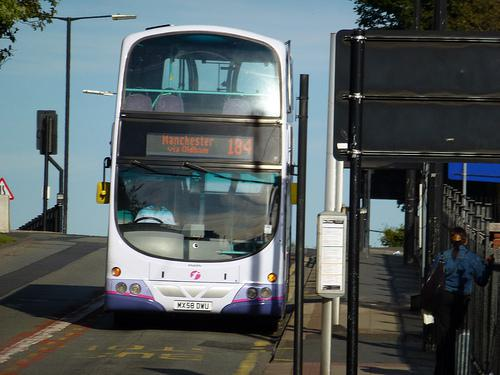Question: what does the large numerical text on the bus display?
Choices:
A. 184.
B. 148.
C. 841.
D. 188.
Answer with the letter. Answer: A Question: how many floors of seats does the bus have?
Choices:
A. One.
B. Three.
C. Four.
D. Two.
Answer with the letter. Answer: D Question: what is the color of the very bottom of the vehicle?
Choices:
A. Blue.
B. Green.
C. Yellow.
D. Red.
Answer with the letter. Answer: A Question: what does the large alphabet text spell out on the bus?
Choices:
A. Manchester.
B. London.
C. Edinburgh.
D. Dublin.
Answer with the letter. Answer: A Question: where in the picture directionally is the blue street sign?
Choices:
A. Right.
B. Left.
C. Back.
D. Front.
Answer with the letter. Answer: A Question: what color is the road line closest to the sidewalk?
Choices:
A. White.
B. Gray.
C. Orange.
D. Yellow.
Answer with the letter. Answer: D 